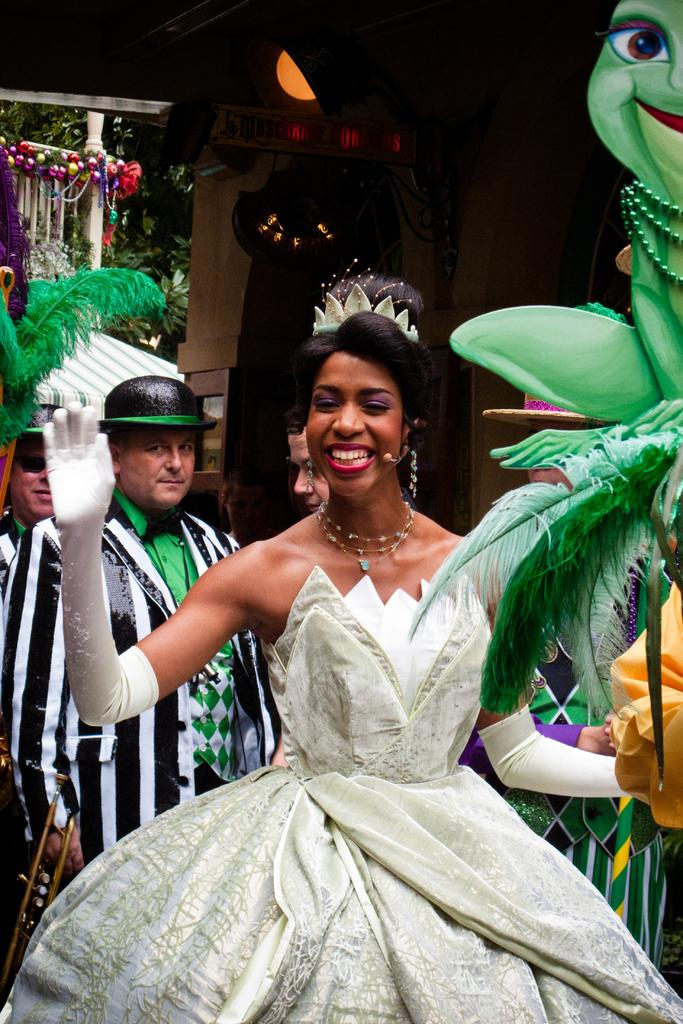What is the person in the foreground of the image doing? The person is standing and smiling in the image. Can you describe the people in the background of the image? There is a group of people standing in the background of the image. What type of objects can be seen in the image? There are decorative items visible in the image. What can be seen in the distance in the image? There are trees and a house in the background of the image. What type of committee is meeting in the image? There is no committee meeting in the image; it features a person standing and smiling, a group of people in the background, decorative items, trees, and a house. 